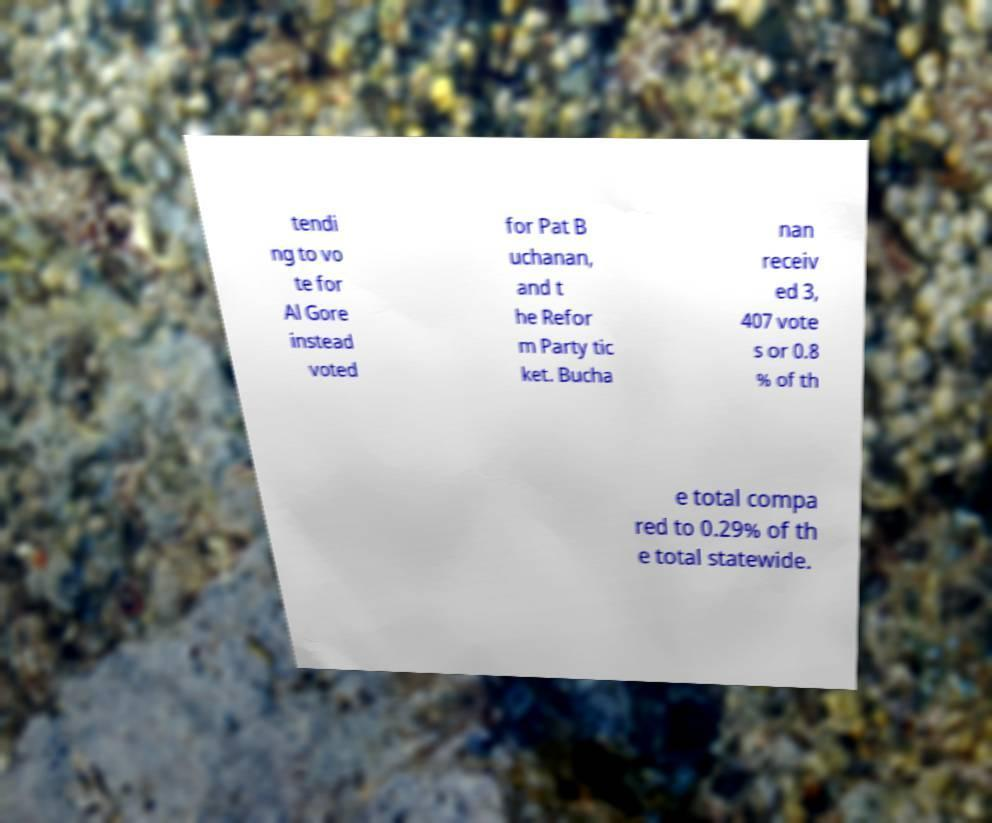For documentation purposes, I need the text within this image transcribed. Could you provide that? tendi ng to vo te for Al Gore instead voted for Pat B uchanan, and t he Refor m Party tic ket. Bucha nan receiv ed 3, 407 vote s or 0.8 % of th e total compa red to 0.29% of th e total statewide. 